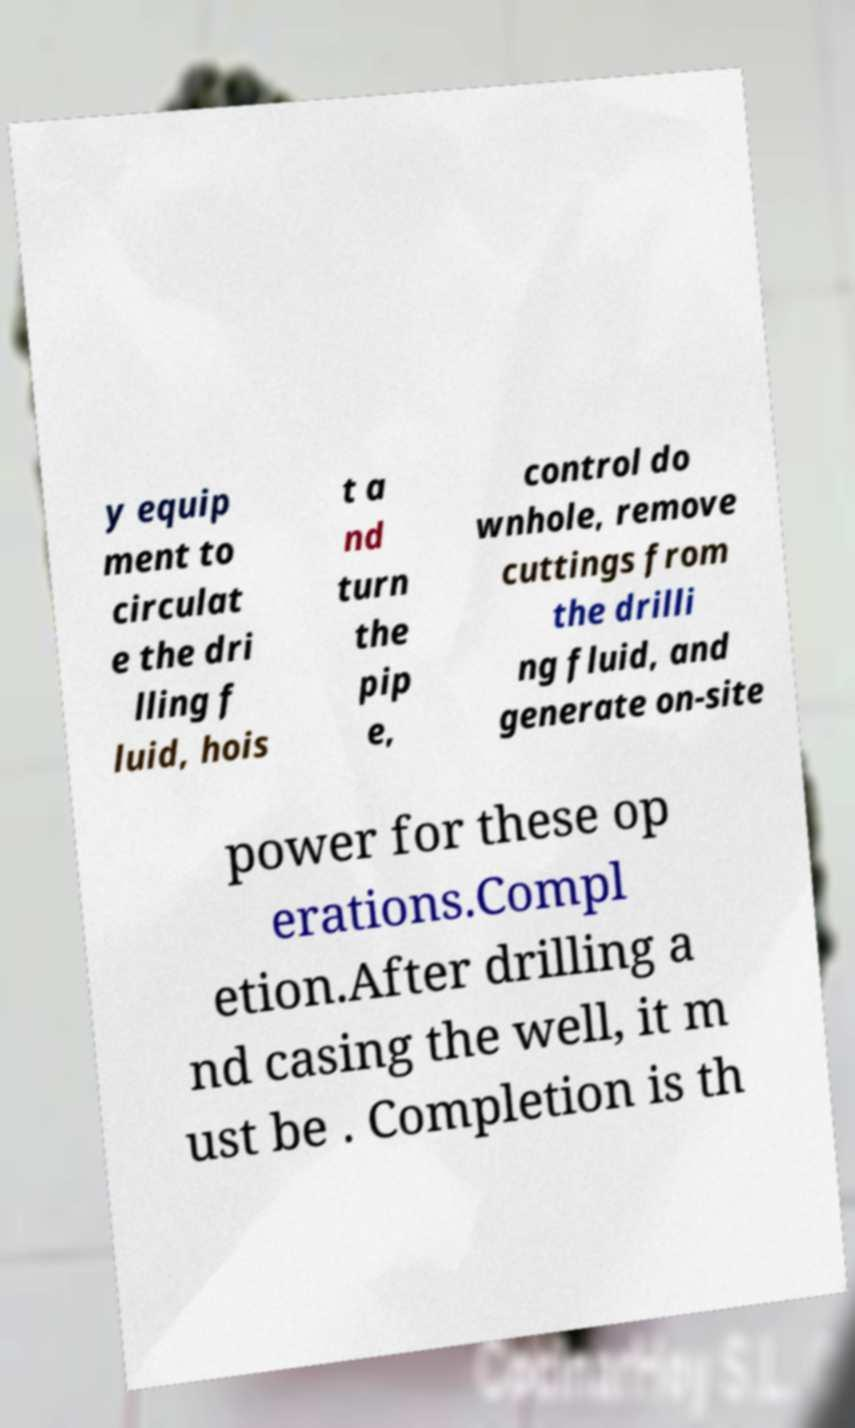There's text embedded in this image that I need extracted. Can you transcribe it verbatim? y equip ment to circulat e the dri lling f luid, hois t a nd turn the pip e, control do wnhole, remove cuttings from the drilli ng fluid, and generate on-site power for these op erations.Compl etion.After drilling a nd casing the well, it m ust be . Completion is th 